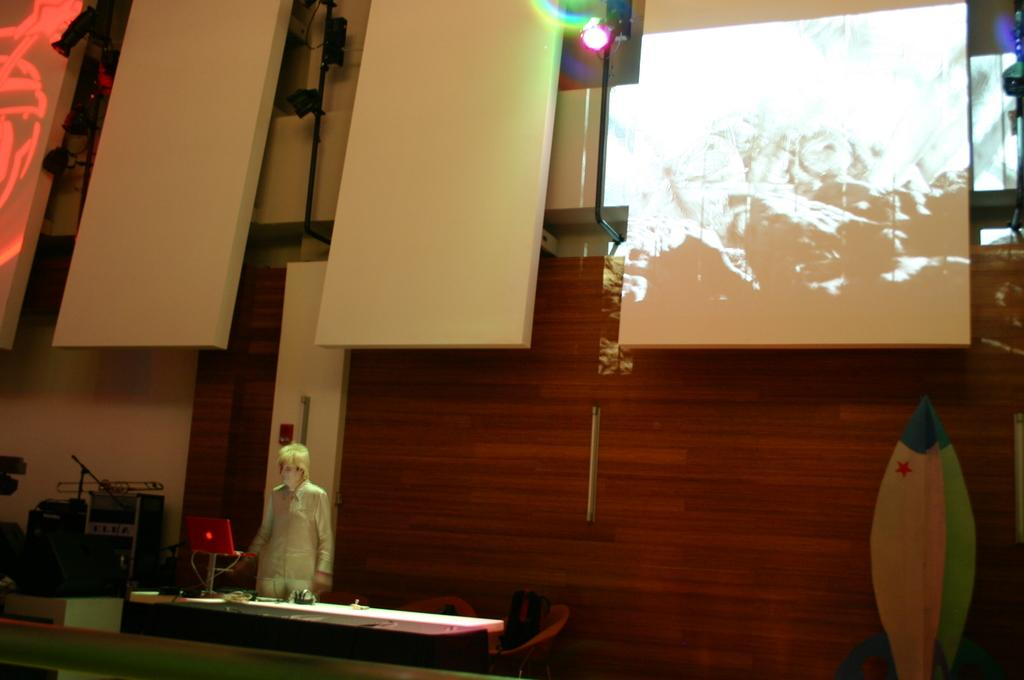What is the main subject in the image? There is a person standing in the image. What is the person standing near in the image? There is a table in the image. What can be seen on the table in the image? A laptop is visible on the table. What is present in the background of the image? There is a wall in the image. What is located on the left side of the image? There are objects on the left side of the image. Is the person in the image feeling regret about the rain? There is no mention of rain or regret in the image, so it cannot be determined if the person is feeling regret about the rain. 